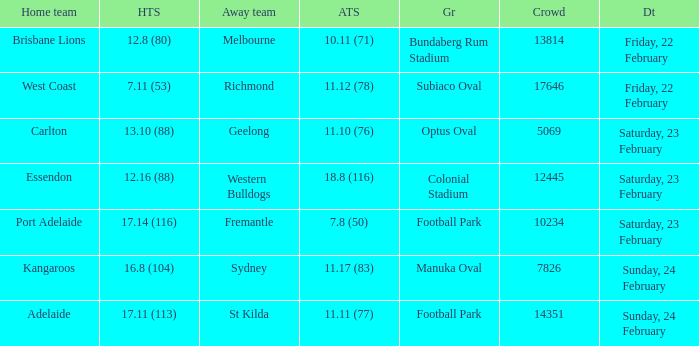On what date did the away team Fremantle play? Saturday, 23 February. 